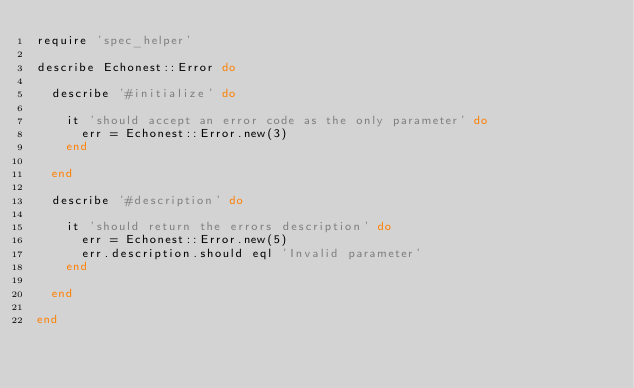Convert code to text. <code><loc_0><loc_0><loc_500><loc_500><_Ruby_>require 'spec_helper'

describe Echonest::Error do

  describe '#initialize' do

    it 'should accept an error code as the only parameter' do
      err = Echonest::Error.new(3)
    end

  end

  describe '#description' do

    it 'should return the errors description' do
      err = Echonest::Error.new(5)
      err.description.should eql 'Invalid parameter'
    end

  end

end</code> 